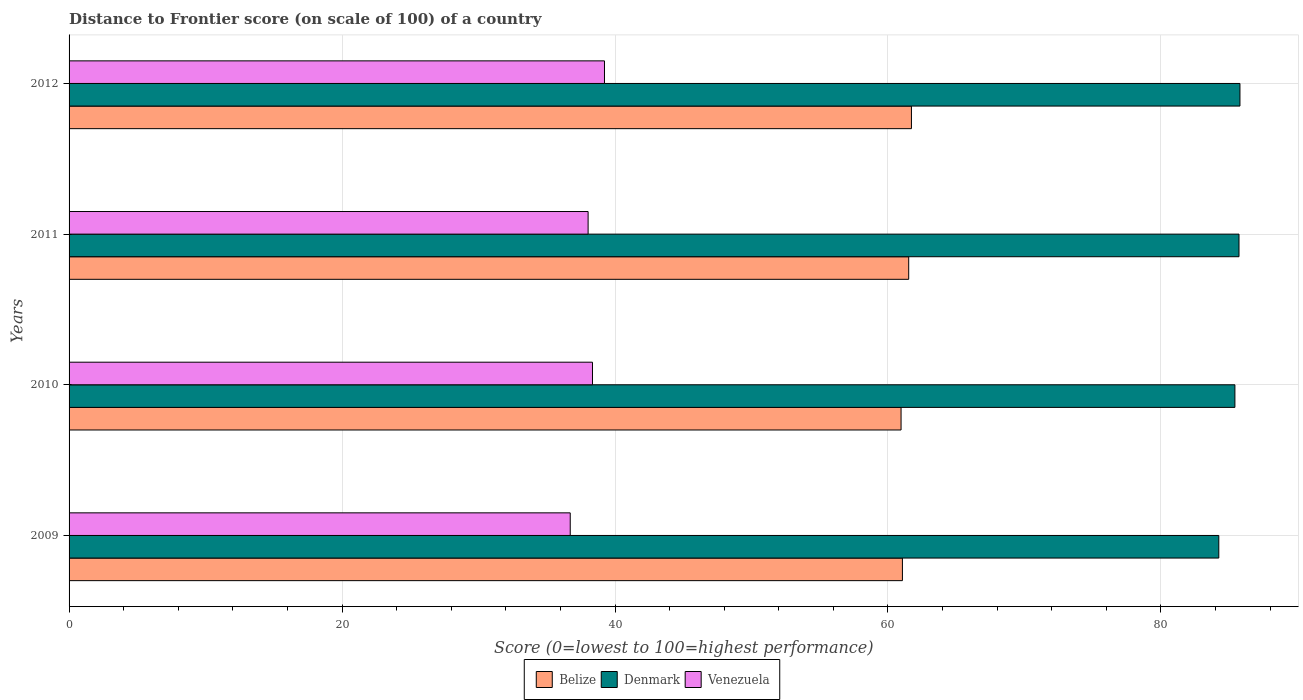How many different coloured bars are there?
Your response must be concise. 3. How many groups of bars are there?
Your answer should be very brief. 4. How many bars are there on the 1st tick from the bottom?
Offer a very short reply. 3. In how many cases, is the number of bars for a given year not equal to the number of legend labels?
Your answer should be compact. 0. What is the distance to frontier score of in Belize in 2009?
Offer a very short reply. 61.06. Across all years, what is the maximum distance to frontier score of in Venezuela?
Your response must be concise. 39.23. Across all years, what is the minimum distance to frontier score of in Belize?
Ensure brevity in your answer.  60.96. In which year was the distance to frontier score of in Belize maximum?
Ensure brevity in your answer.  2012. What is the total distance to frontier score of in Venezuela in the graph?
Provide a succinct answer. 152.33. What is the difference between the distance to frontier score of in Belize in 2009 and that in 2012?
Offer a very short reply. -0.66. What is the difference between the distance to frontier score of in Belize in 2009 and the distance to frontier score of in Denmark in 2012?
Your response must be concise. -24.73. What is the average distance to frontier score of in Belize per year?
Your answer should be compact. 61.32. In the year 2012, what is the difference between the distance to frontier score of in Denmark and distance to frontier score of in Venezuela?
Offer a terse response. 46.56. What is the ratio of the distance to frontier score of in Belize in 2010 to that in 2011?
Your response must be concise. 0.99. Is the distance to frontier score of in Venezuela in 2010 less than that in 2011?
Give a very brief answer. No. What is the difference between the highest and the second highest distance to frontier score of in Venezuela?
Your answer should be very brief. 0.88. What is the difference between the highest and the lowest distance to frontier score of in Venezuela?
Your answer should be very brief. 2.51. What does the 3rd bar from the top in 2012 represents?
Offer a very short reply. Belize. What does the 2nd bar from the bottom in 2009 represents?
Ensure brevity in your answer.  Denmark. Are all the bars in the graph horizontal?
Provide a short and direct response. Yes. Are the values on the major ticks of X-axis written in scientific E-notation?
Your answer should be very brief. No. Does the graph contain any zero values?
Your answer should be compact. No. Does the graph contain grids?
Your response must be concise. Yes. What is the title of the graph?
Offer a very short reply. Distance to Frontier score (on scale of 100) of a country. What is the label or title of the X-axis?
Make the answer very short. Score (0=lowest to 100=highest performance). What is the Score (0=lowest to 100=highest performance) of Belize in 2009?
Provide a short and direct response. 61.06. What is the Score (0=lowest to 100=highest performance) in Denmark in 2009?
Provide a succinct answer. 84.24. What is the Score (0=lowest to 100=highest performance) in Venezuela in 2009?
Give a very brief answer. 36.72. What is the Score (0=lowest to 100=highest performance) of Belize in 2010?
Offer a terse response. 60.96. What is the Score (0=lowest to 100=highest performance) in Denmark in 2010?
Keep it short and to the point. 85.42. What is the Score (0=lowest to 100=highest performance) in Venezuela in 2010?
Offer a very short reply. 38.35. What is the Score (0=lowest to 100=highest performance) in Belize in 2011?
Offer a very short reply. 61.52. What is the Score (0=lowest to 100=highest performance) in Denmark in 2011?
Your answer should be very brief. 85.72. What is the Score (0=lowest to 100=highest performance) of Venezuela in 2011?
Offer a terse response. 38.03. What is the Score (0=lowest to 100=highest performance) of Belize in 2012?
Make the answer very short. 61.72. What is the Score (0=lowest to 100=highest performance) in Denmark in 2012?
Your answer should be very brief. 85.79. What is the Score (0=lowest to 100=highest performance) in Venezuela in 2012?
Make the answer very short. 39.23. Across all years, what is the maximum Score (0=lowest to 100=highest performance) in Belize?
Provide a succinct answer. 61.72. Across all years, what is the maximum Score (0=lowest to 100=highest performance) in Denmark?
Ensure brevity in your answer.  85.79. Across all years, what is the maximum Score (0=lowest to 100=highest performance) in Venezuela?
Provide a succinct answer. 39.23. Across all years, what is the minimum Score (0=lowest to 100=highest performance) in Belize?
Make the answer very short. 60.96. Across all years, what is the minimum Score (0=lowest to 100=highest performance) of Denmark?
Your answer should be compact. 84.24. Across all years, what is the minimum Score (0=lowest to 100=highest performance) in Venezuela?
Ensure brevity in your answer.  36.72. What is the total Score (0=lowest to 100=highest performance) in Belize in the graph?
Offer a very short reply. 245.26. What is the total Score (0=lowest to 100=highest performance) of Denmark in the graph?
Make the answer very short. 341.17. What is the total Score (0=lowest to 100=highest performance) in Venezuela in the graph?
Make the answer very short. 152.33. What is the difference between the Score (0=lowest to 100=highest performance) in Belize in 2009 and that in 2010?
Your response must be concise. 0.1. What is the difference between the Score (0=lowest to 100=highest performance) in Denmark in 2009 and that in 2010?
Your answer should be very brief. -1.18. What is the difference between the Score (0=lowest to 100=highest performance) in Venezuela in 2009 and that in 2010?
Make the answer very short. -1.63. What is the difference between the Score (0=lowest to 100=highest performance) of Belize in 2009 and that in 2011?
Give a very brief answer. -0.46. What is the difference between the Score (0=lowest to 100=highest performance) in Denmark in 2009 and that in 2011?
Your response must be concise. -1.48. What is the difference between the Score (0=lowest to 100=highest performance) in Venezuela in 2009 and that in 2011?
Provide a short and direct response. -1.31. What is the difference between the Score (0=lowest to 100=highest performance) in Belize in 2009 and that in 2012?
Make the answer very short. -0.66. What is the difference between the Score (0=lowest to 100=highest performance) of Denmark in 2009 and that in 2012?
Give a very brief answer. -1.55. What is the difference between the Score (0=lowest to 100=highest performance) of Venezuela in 2009 and that in 2012?
Your response must be concise. -2.51. What is the difference between the Score (0=lowest to 100=highest performance) of Belize in 2010 and that in 2011?
Ensure brevity in your answer.  -0.56. What is the difference between the Score (0=lowest to 100=highest performance) of Venezuela in 2010 and that in 2011?
Your answer should be compact. 0.32. What is the difference between the Score (0=lowest to 100=highest performance) of Belize in 2010 and that in 2012?
Offer a terse response. -0.76. What is the difference between the Score (0=lowest to 100=highest performance) of Denmark in 2010 and that in 2012?
Offer a very short reply. -0.37. What is the difference between the Score (0=lowest to 100=highest performance) in Venezuela in 2010 and that in 2012?
Offer a very short reply. -0.88. What is the difference between the Score (0=lowest to 100=highest performance) in Belize in 2011 and that in 2012?
Ensure brevity in your answer.  -0.2. What is the difference between the Score (0=lowest to 100=highest performance) of Denmark in 2011 and that in 2012?
Your response must be concise. -0.07. What is the difference between the Score (0=lowest to 100=highest performance) in Venezuela in 2011 and that in 2012?
Your response must be concise. -1.2. What is the difference between the Score (0=lowest to 100=highest performance) of Belize in 2009 and the Score (0=lowest to 100=highest performance) of Denmark in 2010?
Offer a very short reply. -24.36. What is the difference between the Score (0=lowest to 100=highest performance) in Belize in 2009 and the Score (0=lowest to 100=highest performance) in Venezuela in 2010?
Provide a succinct answer. 22.71. What is the difference between the Score (0=lowest to 100=highest performance) in Denmark in 2009 and the Score (0=lowest to 100=highest performance) in Venezuela in 2010?
Offer a very short reply. 45.89. What is the difference between the Score (0=lowest to 100=highest performance) of Belize in 2009 and the Score (0=lowest to 100=highest performance) of Denmark in 2011?
Your answer should be very brief. -24.66. What is the difference between the Score (0=lowest to 100=highest performance) of Belize in 2009 and the Score (0=lowest to 100=highest performance) of Venezuela in 2011?
Give a very brief answer. 23.03. What is the difference between the Score (0=lowest to 100=highest performance) of Denmark in 2009 and the Score (0=lowest to 100=highest performance) of Venezuela in 2011?
Provide a succinct answer. 46.21. What is the difference between the Score (0=lowest to 100=highest performance) of Belize in 2009 and the Score (0=lowest to 100=highest performance) of Denmark in 2012?
Provide a short and direct response. -24.73. What is the difference between the Score (0=lowest to 100=highest performance) of Belize in 2009 and the Score (0=lowest to 100=highest performance) of Venezuela in 2012?
Provide a short and direct response. 21.83. What is the difference between the Score (0=lowest to 100=highest performance) of Denmark in 2009 and the Score (0=lowest to 100=highest performance) of Venezuela in 2012?
Ensure brevity in your answer.  45.01. What is the difference between the Score (0=lowest to 100=highest performance) of Belize in 2010 and the Score (0=lowest to 100=highest performance) of Denmark in 2011?
Provide a short and direct response. -24.76. What is the difference between the Score (0=lowest to 100=highest performance) of Belize in 2010 and the Score (0=lowest to 100=highest performance) of Venezuela in 2011?
Your answer should be very brief. 22.93. What is the difference between the Score (0=lowest to 100=highest performance) in Denmark in 2010 and the Score (0=lowest to 100=highest performance) in Venezuela in 2011?
Offer a very short reply. 47.39. What is the difference between the Score (0=lowest to 100=highest performance) of Belize in 2010 and the Score (0=lowest to 100=highest performance) of Denmark in 2012?
Offer a terse response. -24.83. What is the difference between the Score (0=lowest to 100=highest performance) of Belize in 2010 and the Score (0=lowest to 100=highest performance) of Venezuela in 2012?
Provide a succinct answer. 21.73. What is the difference between the Score (0=lowest to 100=highest performance) in Denmark in 2010 and the Score (0=lowest to 100=highest performance) in Venezuela in 2012?
Provide a short and direct response. 46.19. What is the difference between the Score (0=lowest to 100=highest performance) in Belize in 2011 and the Score (0=lowest to 100=highest performance) in Denmark in 2012?
Offer a very short reply. -24.27. What is the difference between the Score (0=lowest to 100=highest performance) in Belize in 2011 and the Score (0=lowest to 100=highest performance) in Venezuela in 2012?
Offer a terse response. 22.29. What is the difference between the Score (0=lowest to 100=highest performance) of Denmark in 2011 and the Score (0=lowest to 100=highest performance) of Venezuela in 2012?
Give a very brief answer. 46.49. What is the average Score (0=lowest to 100=highest performance) of Belize per year?
Provide a short and direct response. 61.31. What is the average Score (0=lowest to 100=highest performance) of Denmark per year?
Your answer should be very brief. 85.29. What is the average Score (0=lowest to 100=highest performance) of Venezuela per year?
Make the answer very short. 38.08. In the year 2009, what is the difference between the Score (0=lowest to 100=highest performance) in Belize and Score (0=lowest to 100=highest performance) in Denmark?
Ensure brevity in your answer.  -23.18. In the year 2009, what is the difference between the Score (0=lowest to 100=highest performance) in Belize and Score (0=lowest to 100=highest performance) in Venezuela?
Your response must be concise. 24.34. In the year 2009, what is the difference between the Score (0=lowest to 100=highest performance) in Denmark and Score (0=lowest to 100=highest performance) in Venezuela?
Your response must be concise. 47.52. In the year 2010, what is the difference between the Score (0=lowest to 100=highest performance) of Belize and Score (0=lowest to 100=highest performance) of Denmark?
Offer a very short reply. -24.46. In the year 2010, what is the difference between the Score (0=lowest to 100=highest performance) of Belize and Score (0=lowest to 100=highest performance) of Venezuela?
Your response must be concise. 22.61. In the year 2010, what is the difference between the Score (0=lowest to 100=highest performance) of Denmark and Score (0=lowest to 100=highest performance) of Venezuela?
Offer a terse response. 47.07. In the year 2011, what is the difference between the Score (0=lowest to 100=highest performance) of Belize and Score (0=lowest to 100=highest performance) of Denmark?
Provide a short and direct response. -24.2. In the year 2011, what is the difference between the Score (0=lowest to 100=highest performance) of Belize and Score (0=lowest to 100=highest performance) of Venezuela?
Provide a short and direct response. 23.49. In the year 2011, what is the difference between the Score (0=lowest to 100=highest performance) of Denmark and Score (0=lowest to 100=highest performance) of Venezuela?
Your answer should be very brief. 47.69. In the year 2012, what is the difference between the Score (0=lowest to 100=highest performance) in Belize and Score (0=lowest to 100=highest performance) in Denmark?
Provide a succinct answer. -24.07. In the year 2012, what is the difference between the Score (0=lowest to 100=highest performance) in Belize and Score (0=lowest to 100=highest performance) in Venezuela?
Give a very brief answer. 22.49. In the year 2012, what is the difference between the Score (0=lowest to 100=highest performance) of Denmark and Score (0=lowest to 100=highest performance) of Venezuela?
Provide a short and direct response. 46.56. What is the ratio of the Score (0=lowest to 100=highest performance) in Belize in 2009 to that in 2010?
Ensure brevity in your answer.  1. What is the ratio of the Score (0=lowest to 100=highest performance) of Denmark in 2009 to that in 2010?
Offer a terse response. 0.99. What is the ratio of the Score (0=lowest to 100=highest performance) in Venezuela in 2009 to that in 2010?
Provide a succinct answer. 0.96. What is the ratio of the Score (0=lowest to 100=highest performance) of Belize in 2009 to that in 2011?
Give a very brief answer. 0.99. What is the ratio of the Score (0=lowest to 100=highest performance) in Denmark in 2009 to that in 2011?
Give a very brief answer. 0.98. What is the ratio of the Score (0=lowest to 100=highest performance) of Venezuela in 2009 to that in 2011?
Provide a succinct answer. 0.97. What is the ratio of the Score (0=lowest to 100=highest performance) of Belize in 2009 to that in 2012?
Give a very brief answer. 0.99. What is the ratio of the Score (0=lowest to 100=highest performance) of Denmark in 2009 to that in 2012?
Ensure brevity in your answer.  0.98. What is the ratio of the Score (0=lowest to 100=highest performance) in Venezuela in 2009 to that in 2012?
Offer a terse response. 0.94. What is the ratio of the Score (0=lowest to 100=highest performance) in Belize in 2010 to that in 2011?
Offer a very short reply. 0.99. What is the ratio of the Score (0=lowest to 100=highest performance) in Denmark in 2010 to that in 2011?
Keep it short and to the point. 1. What is the ratio of the Score (0=lowest to 100=highest performance) in Venezuela in 2010 to that in 2011?
Make the answer very short. 1.01. What is the ratio of the Score (0=lowest to 100=highest performance) of Belize in 2010 to that in 2012?
Offer a terse response. 0.99. What is the ratio of the Score (0=lowest to 100=highest performance) of Denmark in 2010 to that in 2012?
Make the answer very short. 1. What is the ratio of the Score (0=lowest to 100=highest performance) in Venezuela in 2010 to that in 2012?
Keep it short and to the point. 0.98. What is the ratio of the Score (0=lowest to 100=highest performance) of Belize in 2011 to that in 2012?
Offer a very short reply. 1. What is the ratio of the Score (0=lowest to 100=highest performance) in Venezuela in 2011 to that in 2012?
Provide a succinct answer. 0.97. What is the difference between the highest and the second highest Score (0=lowest to 100=highest performance) of Denmark?
Provide a short and direct response. 0.07. What is the difference between the highest and the lowest Score (0=lowest to 100=highest performance) of Belize?
Give a very brief answer. 0.76. What is the difference between the highest and the lowest Score (0=lowest to 100=highest performance) of Denmark?
Make the answer very short. 1.55. What is the difference between the highest and the lowest Score (0=lowest to 100=highest performance) in Venezuela?
Make the answer very short. 2.51. 